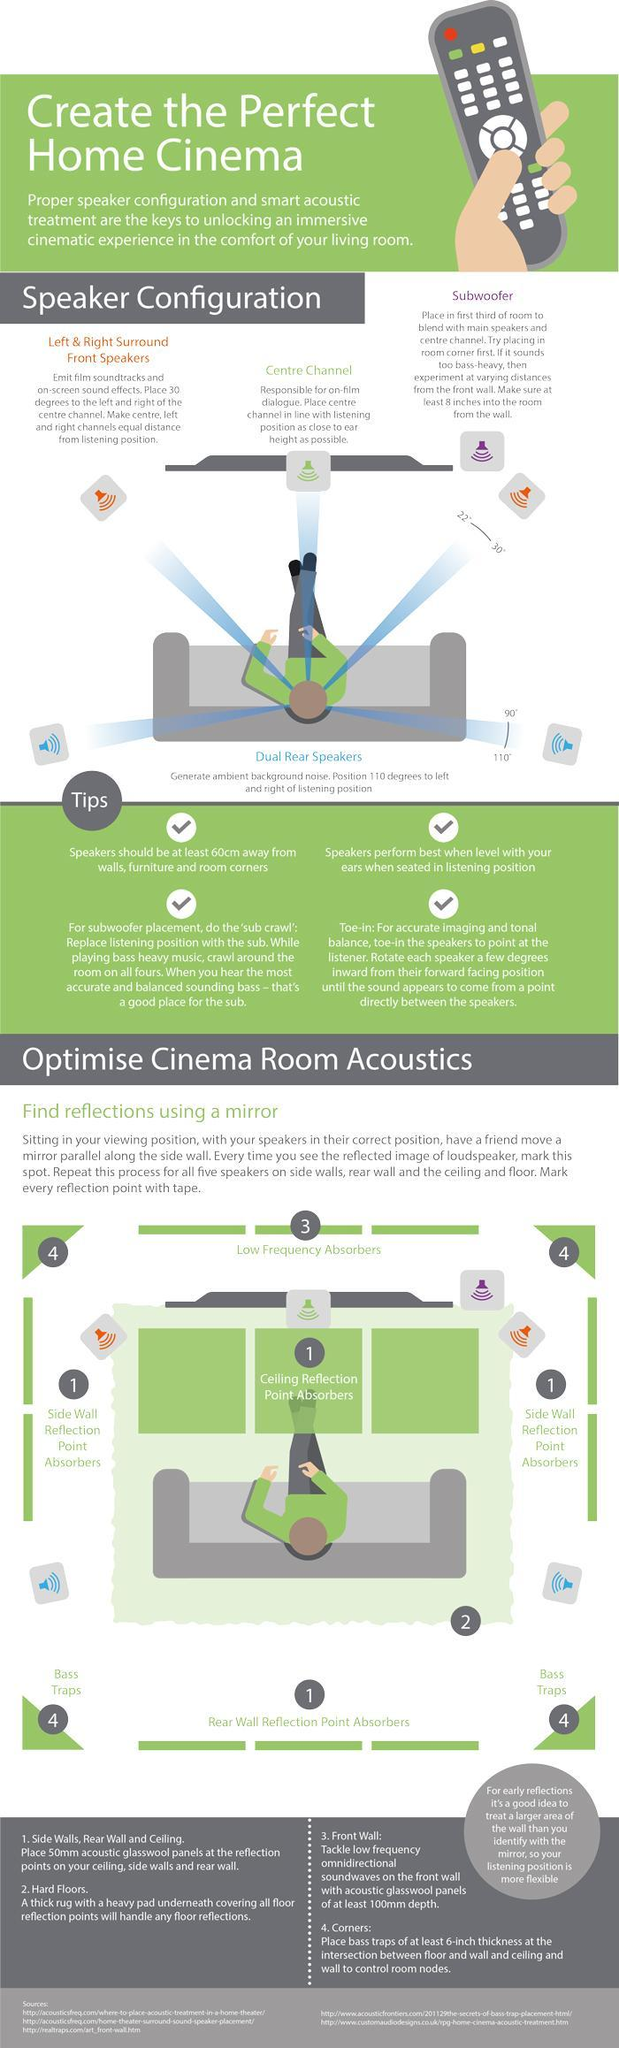What is the color of the speakers placed on the both sides of the viewer in the front,  red, purple, or blue?
Answer the question with a short phrase. red What is the color of the speakers placed in at the back of the viewer, purple, red, or blue? blue What is the direction in which the surround front speakers are to be placed in degrees? 22-30 Which part of the home theatre should be at the centre facing the user ? Centre Channel What is the direction in which the rear speakers are placed in degrees? 90-110 What is the name of the single speaker placed on the right side of the viewer, right surround speaker, rear right dual speaker, or subwoofer ? subwoofer 